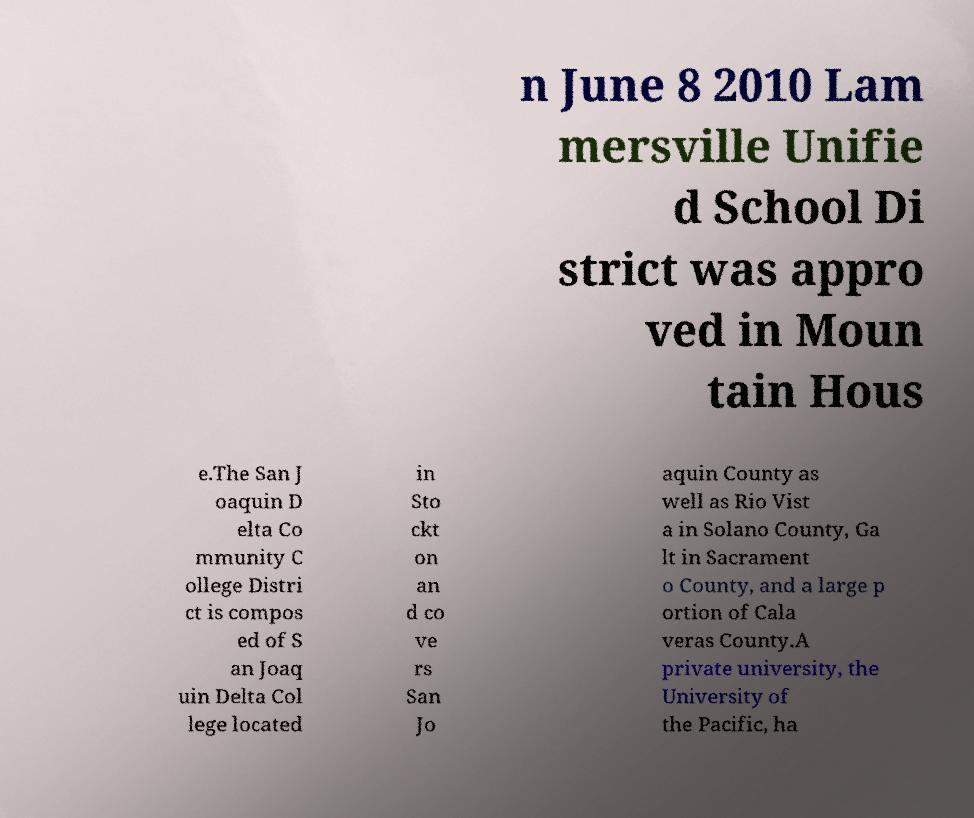I need the written content from this picture converted into text. Can you do that? n June 8 2010 Lam mersville Unifie d School Di strict was appro ved in Moun tain Hous e.The San J oaquin D elta Co mmunity C ollege Distri ct is compos ed of S an Joaq uin Delta Col lege located in Sto ckt on an d co ve rs San Jo aquin County as well as Rio Vist a in Solano County, Ga lt in Sacrament o County, and a large p ortion of Cala veras County.A private university, the University of the Pacific, ha 